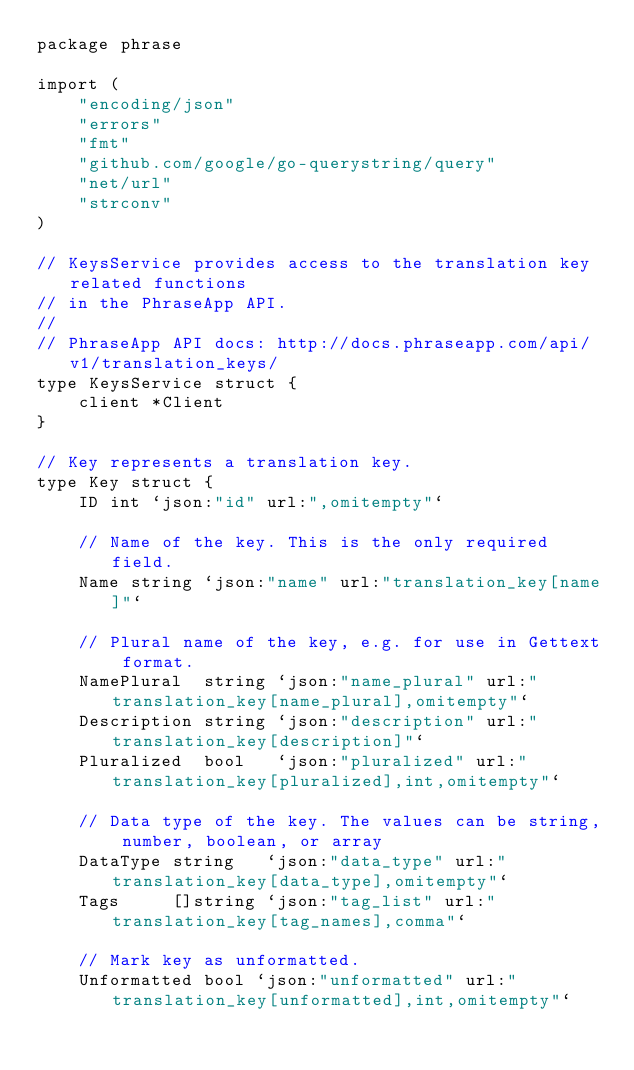<code> <loc_0><loc_0><loc_500><loc_500><_Go_>package phrase

import (
	"encoding/json"
	"errors"
	"fmt"
	"github.com/google/go-querystring/query"
	"net/url"
	"strconv"
)

// KeysService provides access to the translation key related functions
// in the PhraseApp API.
//
// PhraseApp API docs: http://docs.phraseapp.com/api/v1/translation_keys/
type KeysService struct {
	client *Client
}

// Key represents a translation key.
type Key struct {
	ID int `json:"id" url:",omitempty"`

	// Name of the key. This is the only required field.
	Name string `json:"name" url:"translation_key[name]"`

	// Plural name of the key, e.g. for use in Gettext format.
	NamePlural  string `json:"name_plural" url:"translation_key[name_plural],omitempty"`
	Description string `json:"description" url:"translation_key[description]"`
	Pluralized  bool   `json:"pluralized" url:"translation_key[pluralized],int,omitempty"`

	// Data type of the key. The values can be string, number, boolean, or array
	DataType string   `json:"data_type" url:"translation_key[data_type],omitempty"`
	Tags     []string `json:"tag_list" url:"translation_key[tag_names],comma"`

	// Mark key as unformatted.
	Unformatted bool `json:"unformatted" url:"translation_key[unformatted],int,omitempty"`
</code> 